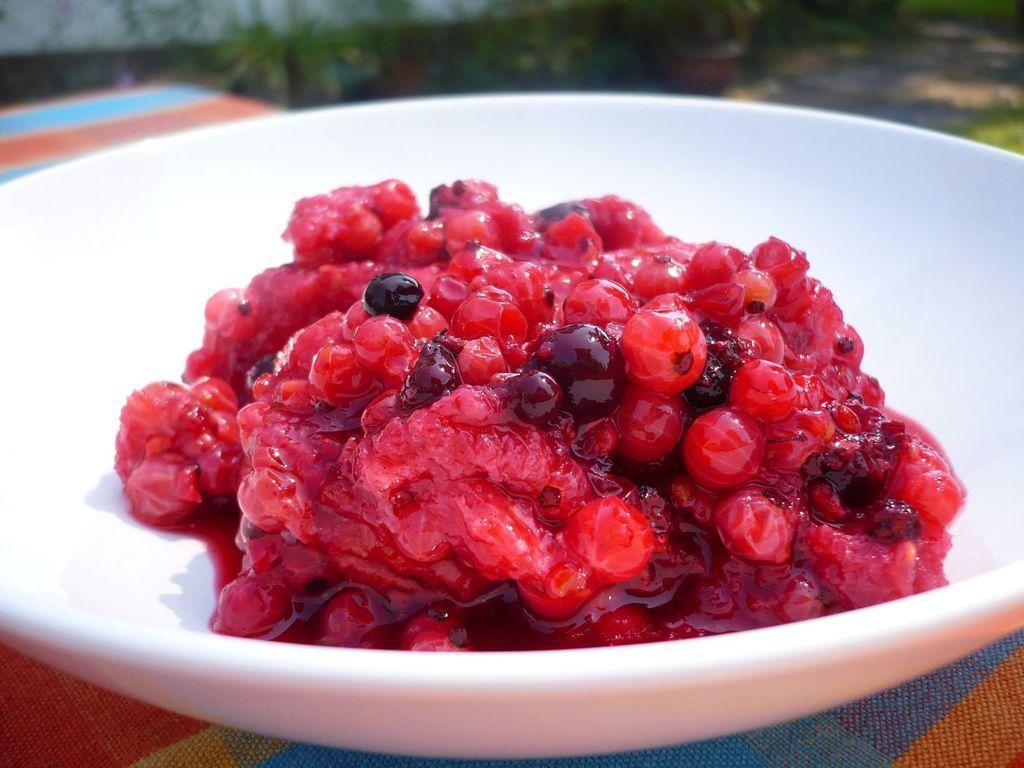How would you summarize this image in a sentence or two? In this image I can see the bowl with food. The bowl is in white color and the food is in red and black color. The bowl is in colorful surface. In the back there are plants and it is blurry. 